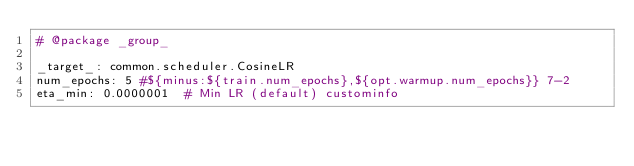<code> <loc_0><loc_0><loc_500><loc_500><_YAML_># @package _group_

_target_: common.scheduler.CosineLR
num_epochs: 5 #${minus:${train.num_epochs},${opt.warmup.num_epochs}} 7-2
eta_min: 0.0000001  # Min LR (default) custominfo
</code> 